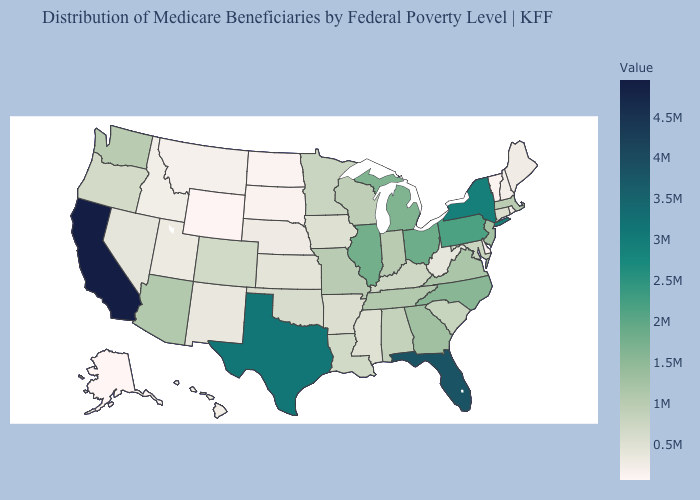Among the states that border Indiana , does Kentucky have the lowest value?
Quick response, please. Yes. Among the states that border Rhode Island , which have the highest value?
Be succinct. Massachusetts. Among the states that border South Dakota , does Iowa have the lowest value?
Concise answer only. No. Which states hav the highest value in the Northeast?
Concise answer only. New York. Does Alabama have a higher value than Nebraska?
Write a very short answer. Yes. Is the legend a continuous bar?
Answer briefly. Yes. 